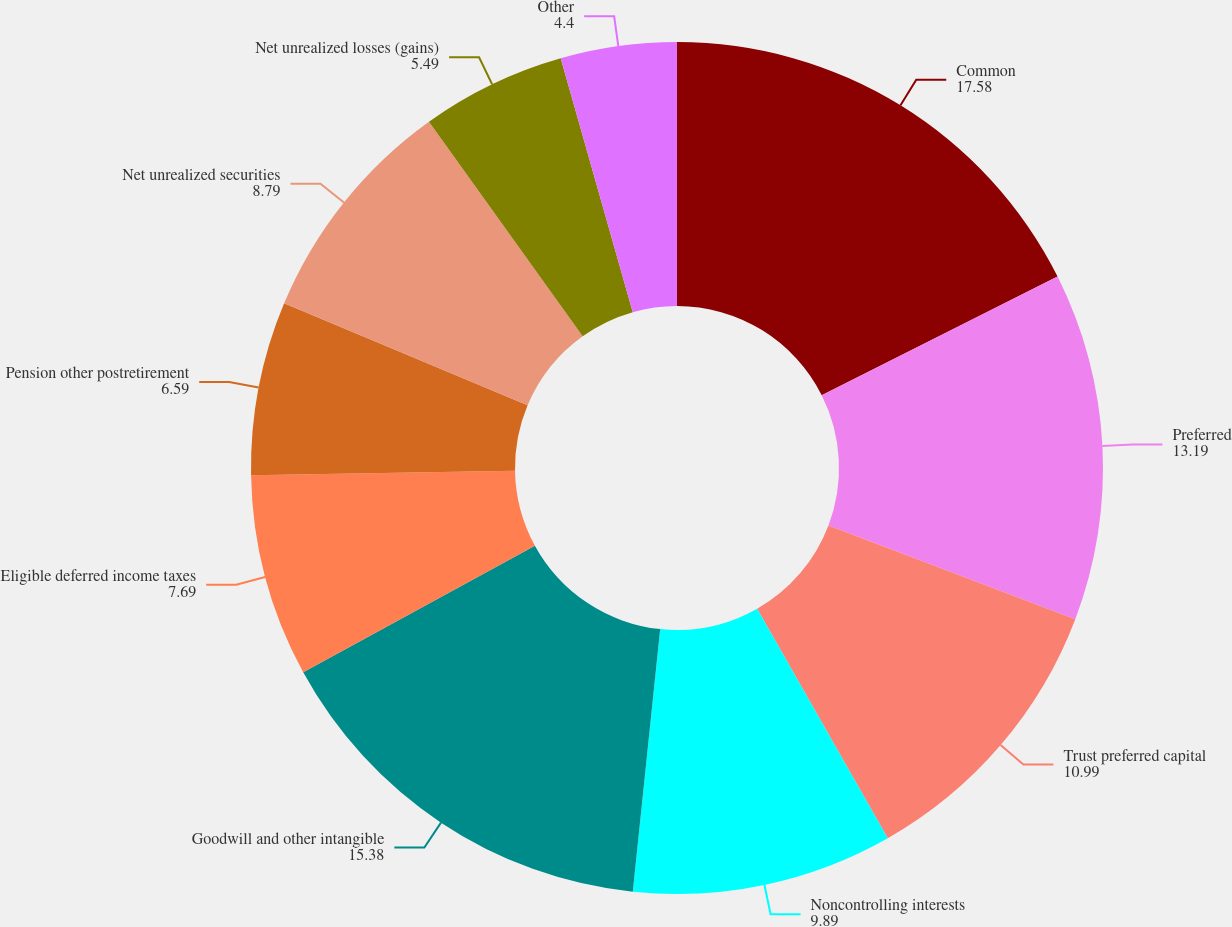<chart> <loc_0><loc_0><loc_500><loc_500><pie_chart><fcel>Common<fcel>Preferred<fcel>Trust preferred capital<fcel>Noncontrolling interests<fcel>Goodwill and other intangible<fcel>Eligible deferred income taxes<fcel>Pension other postretirement<fcel>Net unrealized securities<fcel>Net unrealized losses (gains)<fcel>Other<nl><fcel>17.58%<fcel>13.19%<fcel>10.99%<fcel>9.89%<fcel>15.38%<fcel>7.69%<fcel>6.59%<fcel>8.79%<fcel>5.49%<fcel>4.4%<nl></chart> 